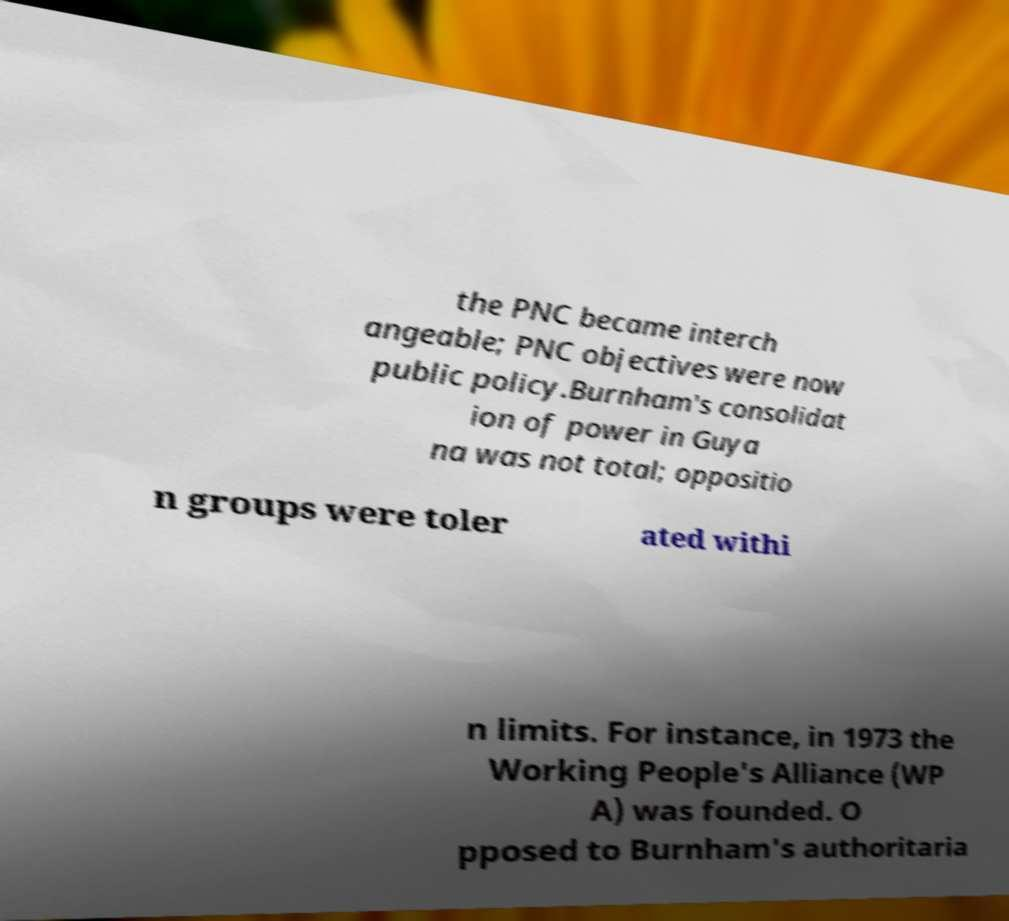What messages or text are displayed in this image? I need them in a readable, typed format. the PNC became interch angeable; PNC objectives were now public policy.Burnham's consolidat ion of power in Guya na was not total; oppositio n groups were toler ated withi n limits. For instance, in 1973 the Working People's Alliance (WP A) was founded. O pposed to Burnham's authoritaria 